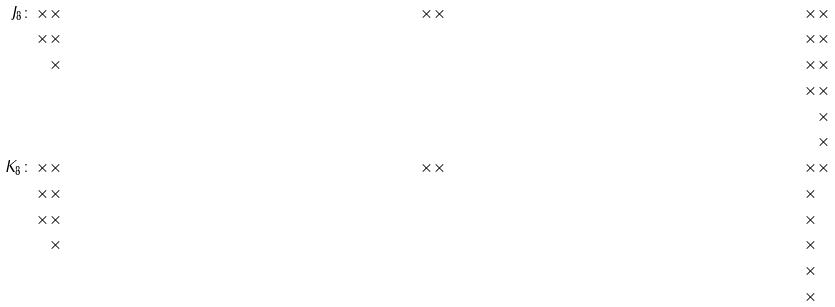<formula> <loc_0><loc_0><loc_500><loc_500>J _ { 8 } \colon \, \times & \times & \times & \times & \times & \times \\ \times & \times & & & \times & \times \\ & \times & & & \times & \times \\ & & & & \times & \times \\ & & & & & \times \\ & & & & & \times \\ \quad K _ { 8 } \colon \, \times & \times & \times & \times & \times & \times \\ \times & \times & & & \times & \\ \times & \times & & & \times & \\ & \times & & & \times & \\ & & & & \times & \\ & & & & \times & \\</formula> 